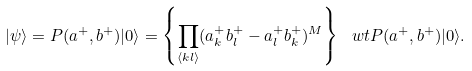Convert formula to latex. <formula><loc_0><loc_0><loc_500><loc_500>| \psi \rangle = P ( a ^ { + } , b ^ { + } ) | 0 \rangle = \left \{ \prod _ { \langle k l \rangle } ( a ^ { + } _ { k } b ^ { + } _ { l } - a ^ { + } _ { l } b ^ { + } _ { k } ) ^ { M } \right \} \ w t P ( a ^ { + } , b ^ { + } ) | 0 \rangle .</formula> 